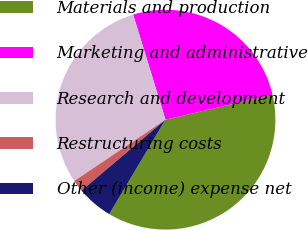Convert chart to OTSL. <chart><loc_0><loc_0><loc_500><loc_500><pie_chart><fcel>Materials and production<fcel>Marketing and administrative<fcel>Research and development<fcel>Restructuring costs<fcel>Other (income) expense net<nl><fcel>37.18%<fcel>26.13%<fcel>29.67%<fcel>1.74%<fcel>5.29%<nl></chart> 